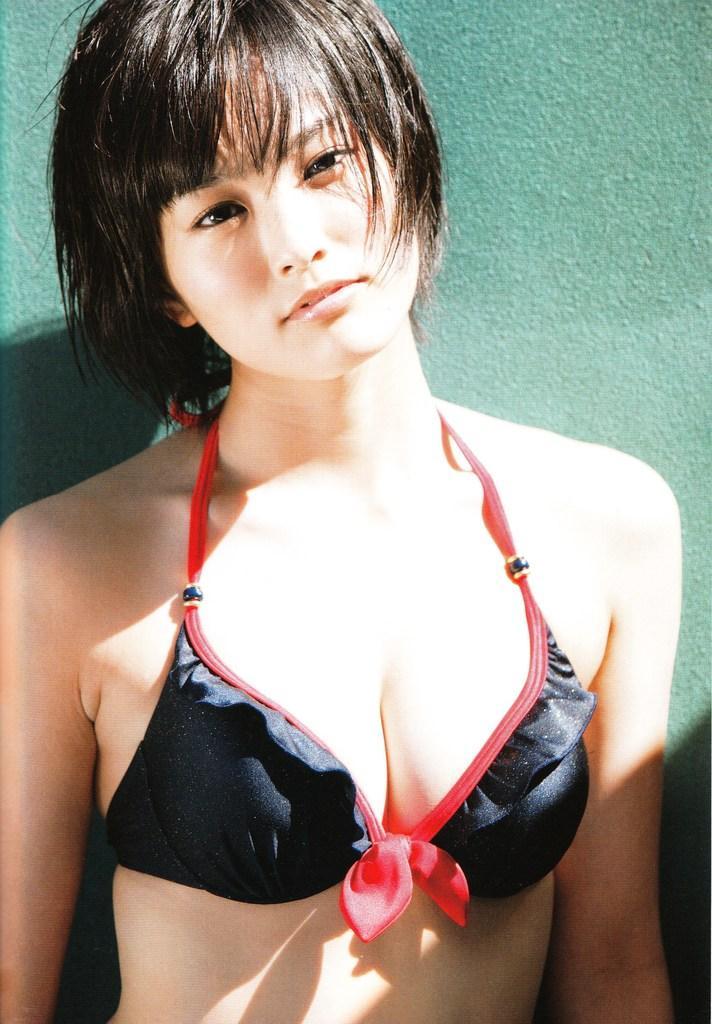Please provide a concise description of this image. In this picture, we see a woman is standing and she is posing for the photo. Behind her, we see a wall which is green in color. 